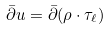<formula> <loc_0><loc_0><loc_500><loc_500>\bar { \partial } u = \bar { \partial } ( \rho \cdot \tau _ { \ell } )</formula> 